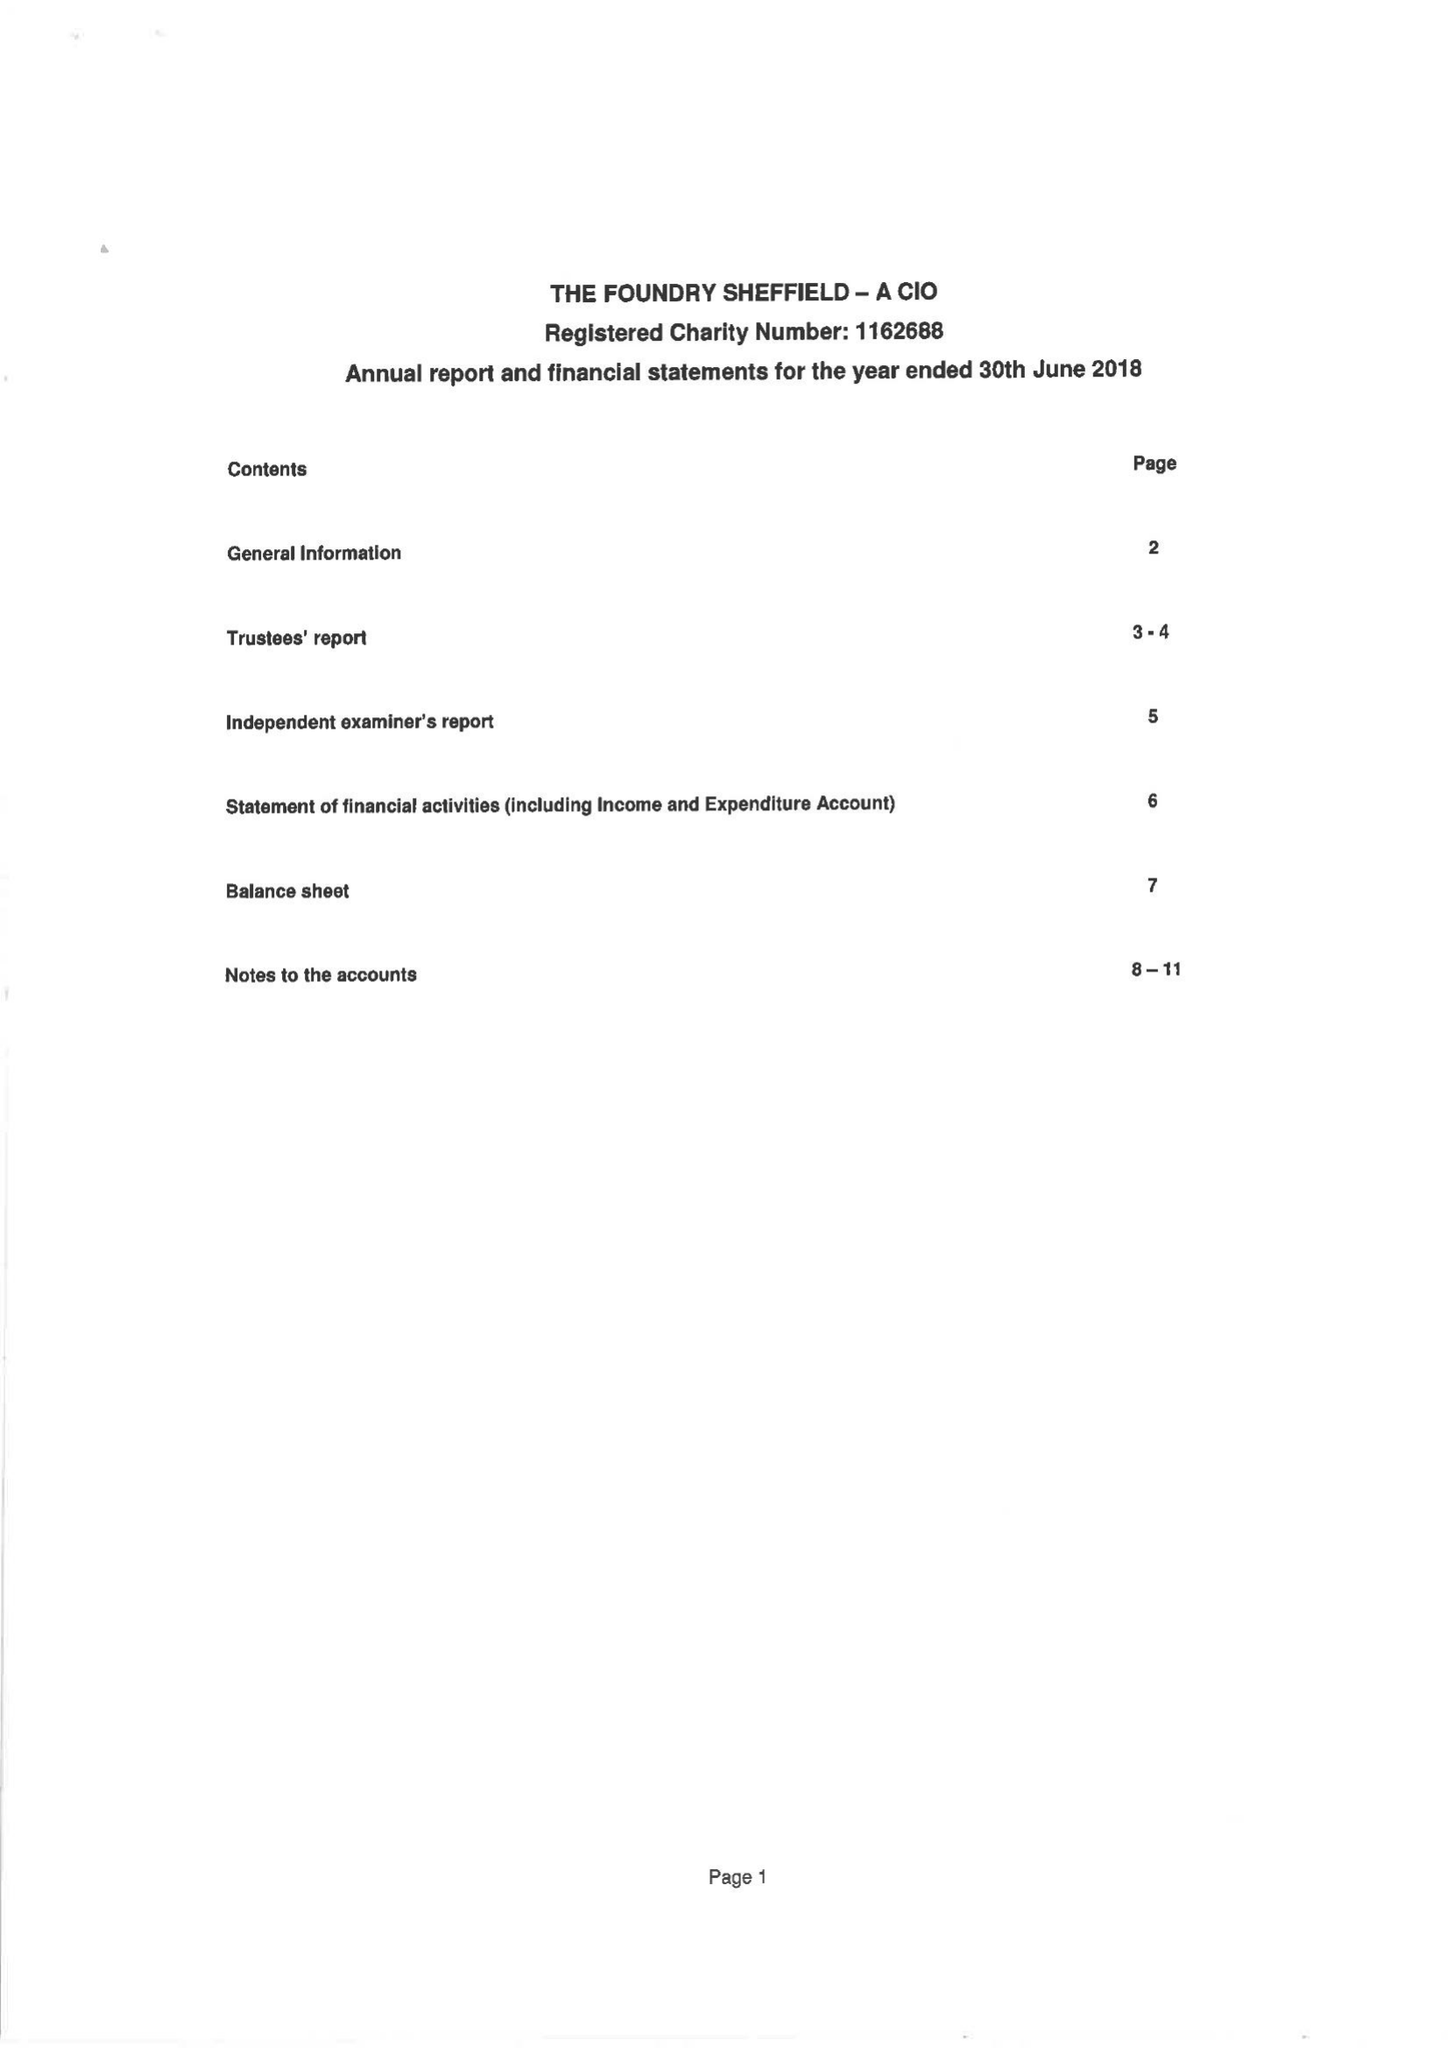What is the value for the address__postcode?
Answer the question using a single word or phrase. S1 2JB 